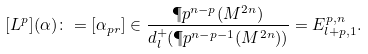Convert formula to latex. <formula><loc_0><loc_0><loc_500><loc_500>[ L ^ { p } ] ( \alpha ) \colon = [ \alpha _ { p r } ] \in \frac { \P p ^ { n - p } ( M ^ { 2 n } ) } { d _ { l } ^ { + } ( \P p ^ { n - p - 1 } ( M ^ { 2 n } ) ) } = E ^ { p , n } _ { l + p , 1 } .</formula> 